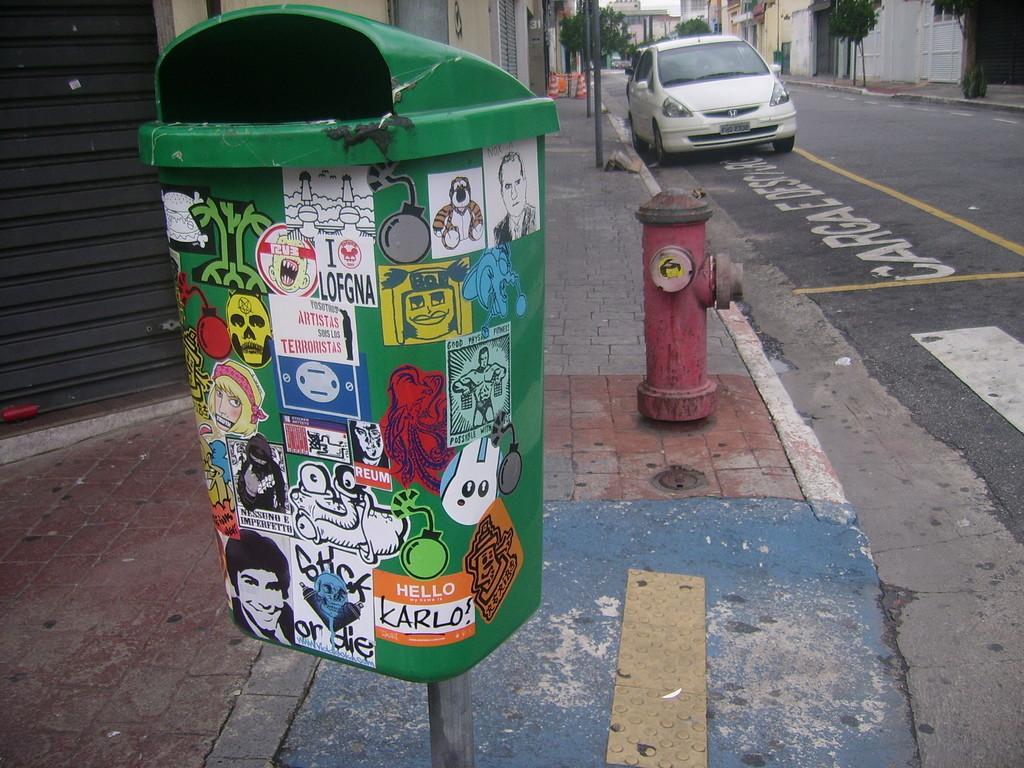Please provide a concise description of this image. In this picture there is a dust bin and a water pump in the center of the image and there is a car at the top side of the image and there are buildings, trees, and poles at the top side of the image. 